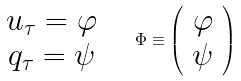<formula> <loc_0><loc_0><loc_500><loc_500>\begin{array} { c } u _ { \tau } = \varphi \\ q _ { \tau } = \psi \end{array} \quad \Phi \equiv \left ( \begin{array} { c } \varphi \\ \psi \end{array} \right )</formula> 